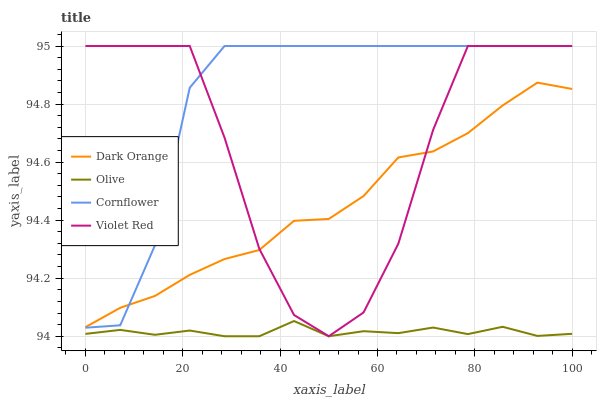Does Olive have the minimum area under the curve?
Answer yes or no. Yes. Does Cornflower have the maximum area under the curve?
Answer yes or no. Yes. Does Dark Orange have the minimum area under the curve?
Answer yes or no. No. Does Dark Orange have the maximum area under the curve?
Answer yes or no. No. Is Olive the smoothest?
Answer yes or no. Yes. Is Violet Red the roughest?
Answer yes or no. Yes. Is Dark Orange the smoothest?
Answer yes or no. No. Is Dark Orange the roughest?
Answer yes or no. No. Does Olive have the lowest value?
Answer yes or no. Yes. Does Violet Red have the lowest value?
Answer yes or no. No. Does Cornflower have the highest value?
Answer yes or no. Yes. Does Dark Orange have the highest value?
Answer yes or no. No. Is Olive less than Dark Orange?
Answer yes or no. Yes. Is Dark Orange greater than Olive?
Answer yes or no. Yes. Does Violet Red intersect Cornflower?
Answer yes or no. Yes. Is Violet Red less than Cornflower?
Answer yes or no. No. Is Violet Red greater than Cornflower?
Answer yes or no. No. Does Olive intersect Dark Orange?
Answer yes or no. No. 